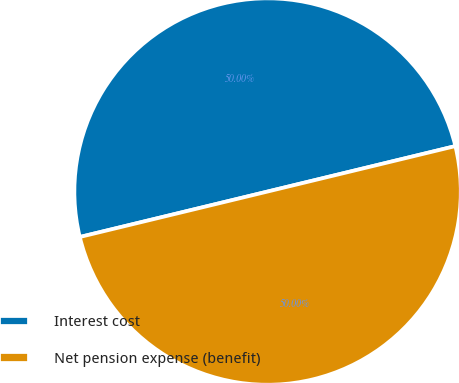Convert chart to OTSL. <chart><loc_0><loc_0><loc_500><loc_500><pie_chart><fcel>Interest cost<fcel>Net pension expense (benefit)<nl><fcel>50.0%<fcel>50.0%<nl></chart> 